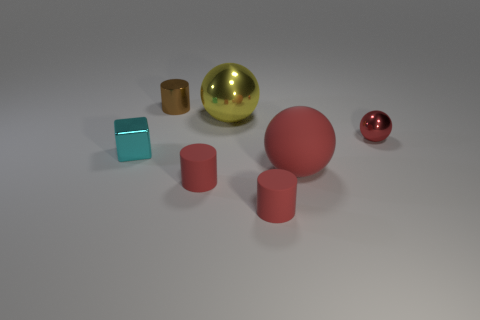What number of other things are there of the same size as the brown cylinder?
Give a very brief answer. 4. What number of objects are both behind the block and left of the red metallic sphere?
Give a very brief answer. 2. There is a metallic object left of the brown metal thing; is it the same size as the red ball that is behind the big red matte object?
Offer a very short reply. Yes. There is a sphere in front of the cyan metal cube; what is its size?
Make the answer very short. Large. What number of objects are either small red metallic things behind the cube or tiny cylinders in front of the tiny brown object?
Offer a terse response. 3. Is there any other thing that has the same color as the matte sphere?
Your response must be concise. Yes. Are there the same number of matte things behind the red rubber ball and small red spheres behind the small brown metallic cylinder?
Make the answer very short. Yes. Are there more big balls behind the tiny metal cube than red spheres?
Offer a very short reply. No. What number of things are small things that are in front of the small cyan shiny object or tiny red shiny things?
Give a very brief answer. 3. How many tiny cylinders are the same material as the tiny cyan block?
Your answer should be very brief. 1. 